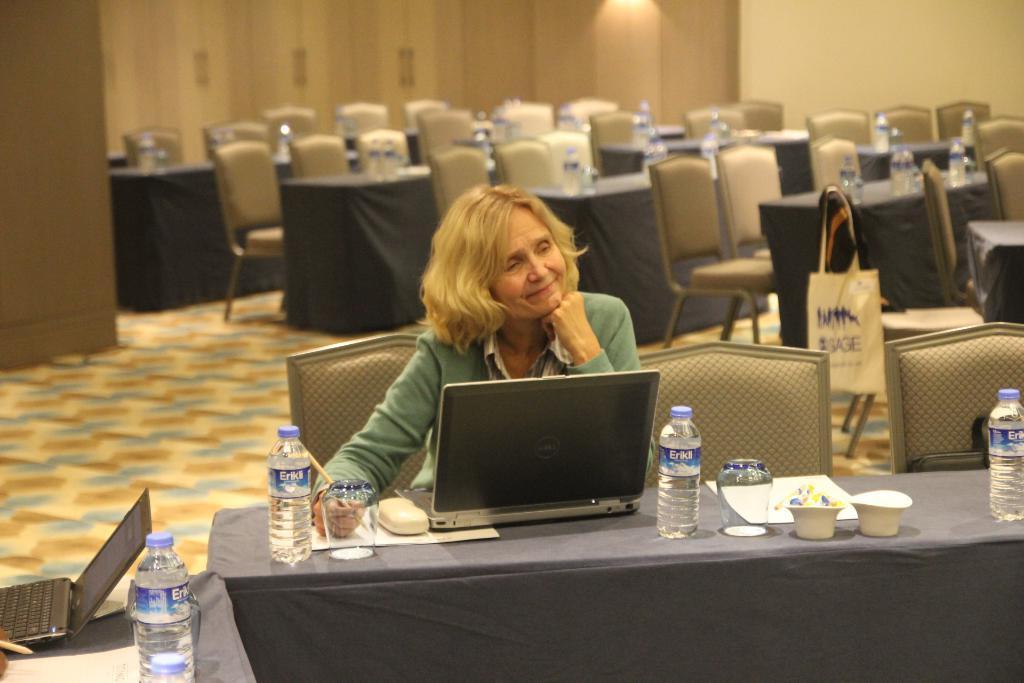Describe this image in one or two sentences. This woman is sitting on a chair. In-front of this woman there is a table, on a table there are bowls, paper, jar and bottles. In-front of this woman there is a laptop. We can able to see a number of chairs and number of tables. This woman is holding a pen. On this chair there is a bag. 